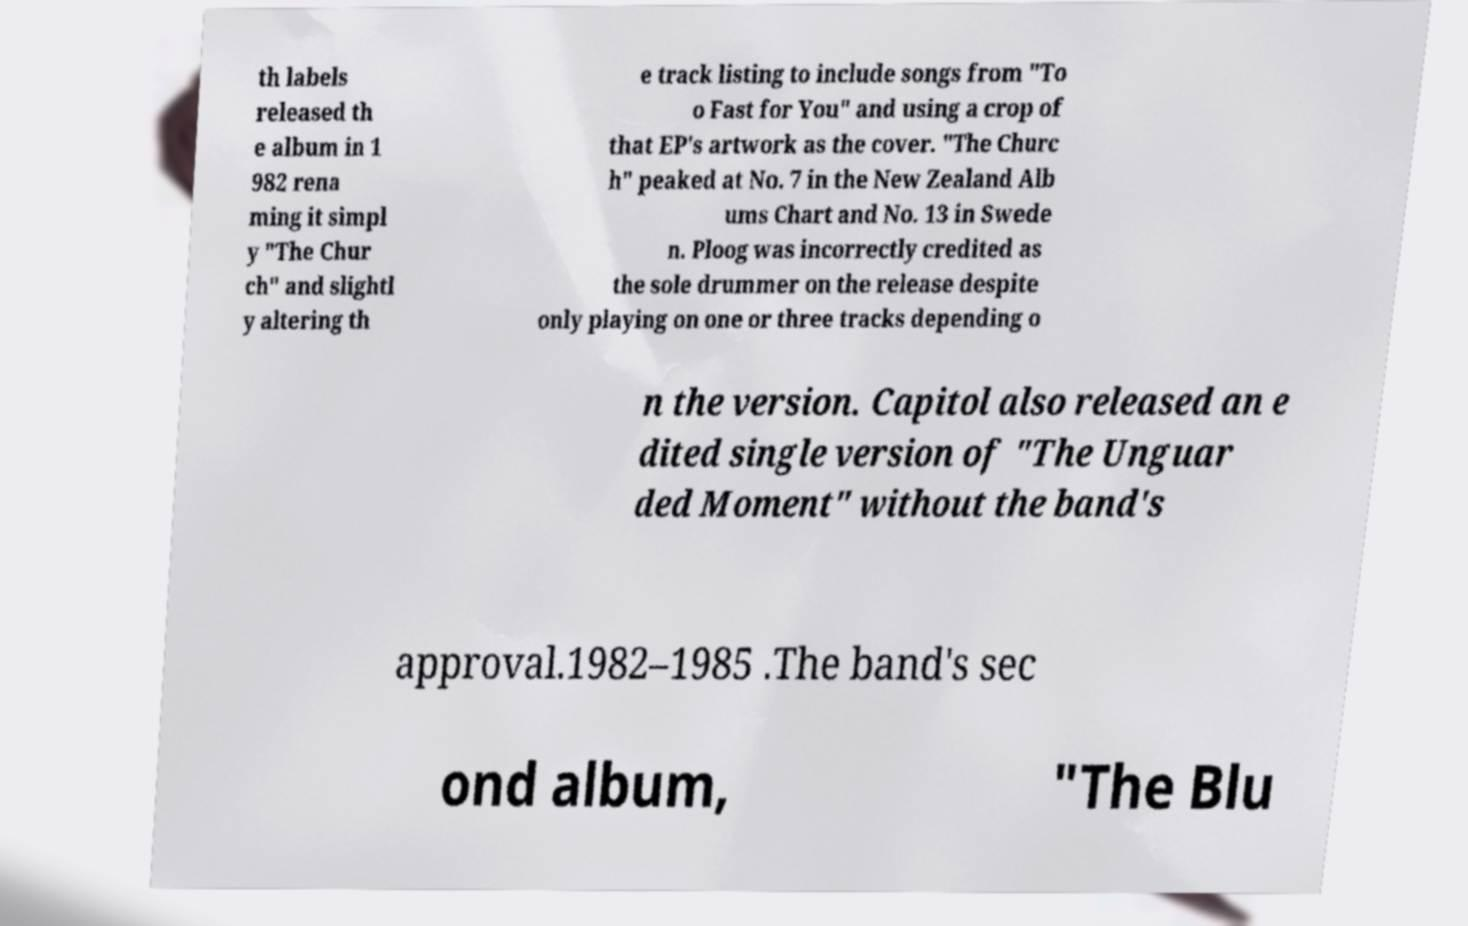Please identify and transcribe the text found in this image. th labels released th e album in 1 982 rena ming it simpl y "The Chur ch" and slightl y altering th e track listing to include songs from "To o Fast for You" and using a crop of that EP's artwork as the cover. "The Churc h" peaked at No. 7 in the New Zealand Alb ums Chart and No. 13 in Swede n. Ploog was incorrectly credited as the sole drummer on the release despite only playing on one or three tracks depending o n the version. Capitol also released an e dited single version of "The Unguar ded Moment" without the band's approval.1982–1985 .The band's sec ond album, "The Blu 